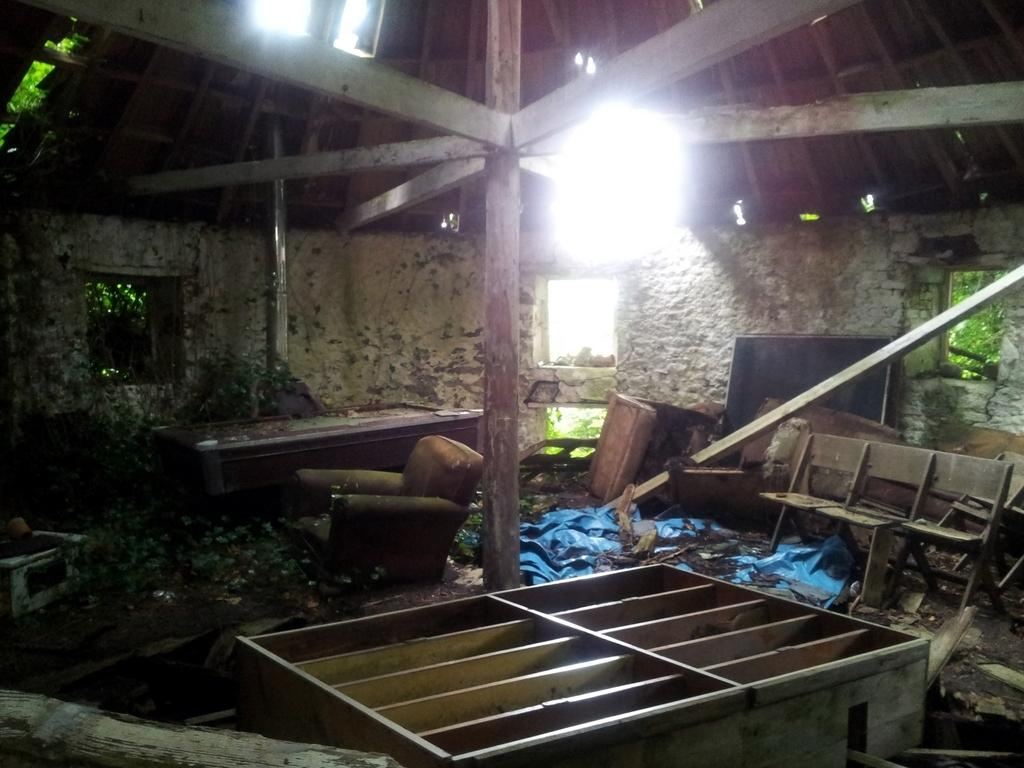What type of building is shown in the image? The image is of an old house. What can be seen on the exterior of the house? There is a wall in the image. Are there any openings in the wall? Yes, there are windows in the image. What furniture is visible in the image? There are chairs in the image. Is there any storage space visible? Yes, there is a rack in the image. What surface can be used for placing items? There is a table in the image. What can be seen through the windows? Leaves are visible through the windows. What type of food is being served on the board in the image? There is no board or food present in the image. What thrilling activity is taking place in the image? There is no thrilling activity depicted in the image; it shows an old house with various elements. 